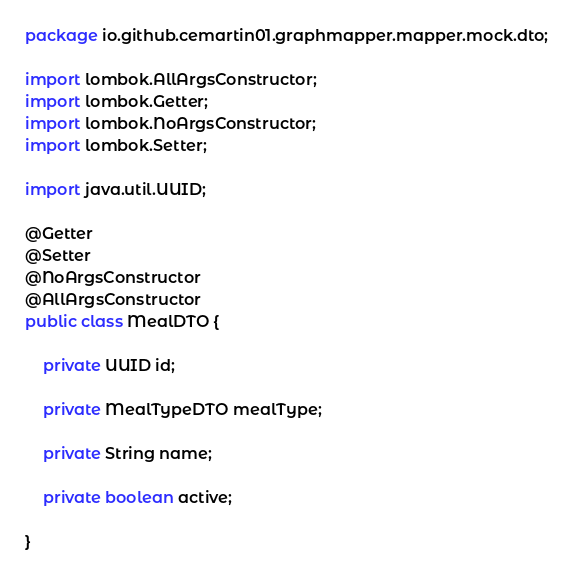Convert code to text. <code><loc_0><loc_0><loc_500><loc_500><_Java_>package io.github.cemartin01.graphmapper.mapper.mock.dto;

import lombok.AllArgsConstructor;
import lombok.Getter;
import lombok.NoArgsConstructor;
import lombok.Setter;

import java.util.UUID;

@Getter
@Setter
@NoArgsConstructor
@AllArgsConstructor
public class MealDTO {

    private UUID id;

    private MealTypeDTO mealType;

    private String name;

    private boolean active;

}
</code> 